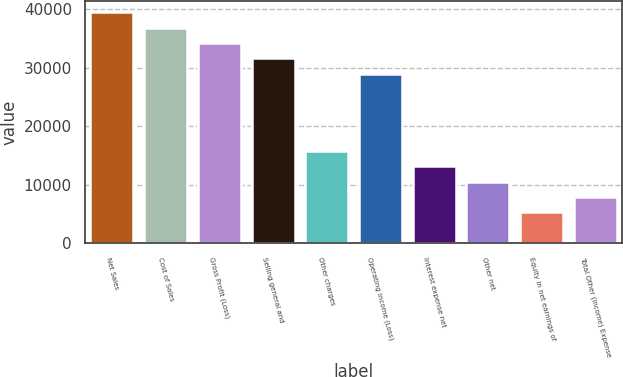<chart> <loc_0><loc_0><loc_500><loc_500><bar_chart><fcel>Net Sales<fcel>Cost of Sales<fcel>Gross Profit (Loss)<fcel>Selling general and<fcel>Other charges<fcel>Operating Income (Loss)<fcel>Interest expense net<fcel>Other net<fcel>Equity in net earnings of<fcel>Total Other (Income) Expense<nl><fcel>39433.9<fcel>36805.1<fcel>34176.3<fcel>31547.5<fcel>15774.8<fcel>28918.7<fcel>13146.1<fcel>10517.3<fcel>5259.72<fcel>7888.5<nl></chart> 